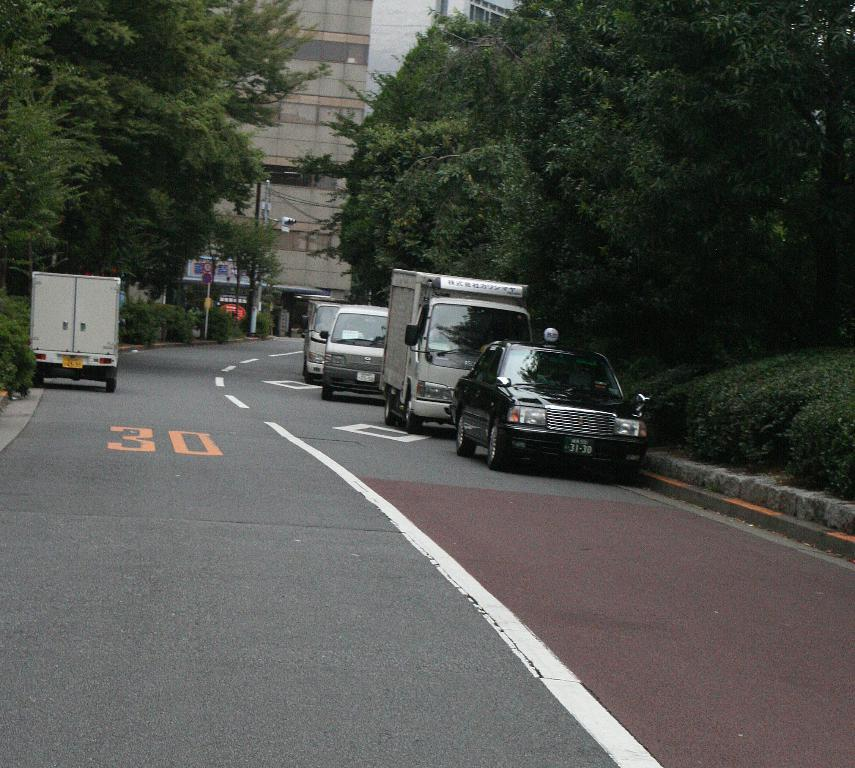What can be seen on the road in the image? There are vehicles on the road in the image. What type of vegetation is present in the image? There are plants and trees in the image. What is the purpose of the sign board in the image? The purpose of the sign board in the image is to provide information or directions. What is the pole used for in the image? The pole in the image might be used for supporting a sign or a light. What type of structure is visible in the image? There is a building in the image. What part of the natural environment is visible in the image? The sky is visible in the image. Can you see a beam of light coming from the nose of the building in the image? There is no beam of light coming from the nose of the building in the image, as buildings do not have noses. 